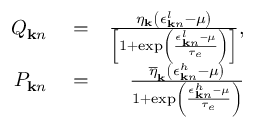Convert formula to latex. <formula><loc_0><loc_0><loc_500><loc_500>\begin{array} { r l r } { Q _ { { k } n } } & = } & { \frac { \eta _ { k } \left ( \epsilon _ { { k } n } ^ { l } - \mu \right ) } { \left [ 1 + \exp \left ( \frac { \epsilon _ { { k } n } ^ { l } - \mu } { \tau _ { e } } \right ) \right ] } , } \\ { P _ { { k } n } } & = } & { \frac { \overline { \eta } _ { k } \left ( \epsilon _ { { k } n } ^ { h } - \mu \right ) } { 1 + \exp \left ( \frac { \epsilon _ { { k } n } ^ { h } - \mu } { \tau _ { e } } \right ) } } \end{array}</formula> 